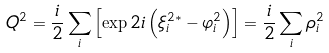<formula> <loc_0><loc_0><loc_500><loc_500>Q ^ { 2 } = \frac { i } { 2 } \sum _ { i } \left [ \exp 2 i \left ( \xi _ { i } ^ { 2 \ast } - \varphi _ { i } ^ { 2 } \right ) \right ] = \frac { i } { 2 } \sum _ { i } \rho _ { i } ^ { 2 }</formula> 